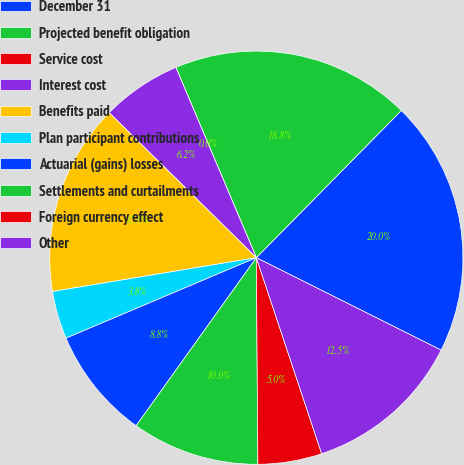<chart> <loc_0><loc_0><loc_500><loc_500><pie_chart><fcel>December 31<fcel>Projected benefit obligation<fcel>Service cost<fcel>Interest cost<fcel>Benefits paid<fcel>Plan participant contributions<fcel>Actuarial (gains) losses<fcel>Settlements and curtailments<fcel>Foreign currency effect<fcel>Other<nl><fcel>20.0%<fcel>18.75%<fcel>0.0%<fcel>6.25%<fcel>15.0%<fcel>3.75%<fcel>8.75%<fcel>10.0%<fcel>5.0%<fcel>12.5%<nl></chart> 